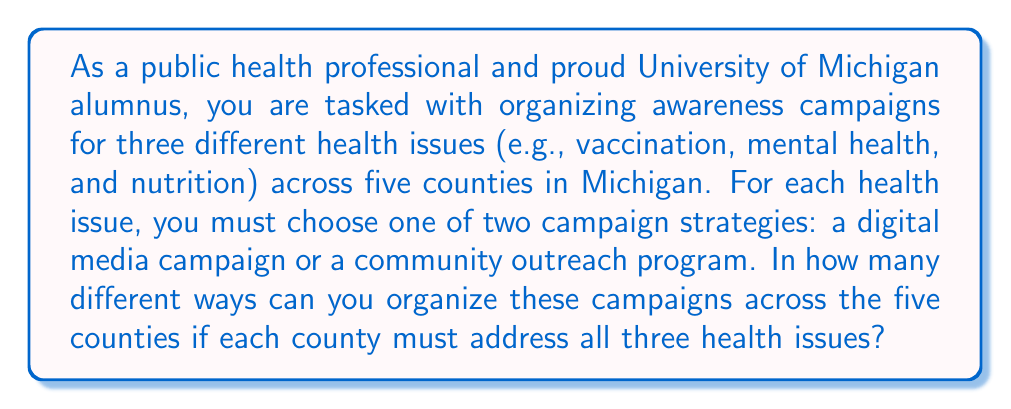Can you solve this math problem? Let's approach this step-by-step:

1) For each county, we need to make three independent decisions, one for each health issue.

2) For each health issue in each county, we have two choices: digital media campaign or community outreach program.

3) This scenario can be modeled as a sequence of choices, where we make 3 choices for each of the 5 counties.

4) For each individual choice, we have 2 options.

5) When we have a sequence of independent choices, we multiply the number of options for each choice.

6) In this case, we have:
   $$(2 \text{ choices})^{3 \text{ health issues}} = 2^3 = 8$$ possible combinations for each county.

7) We need to make this decision for each of the 5 counties independently.

8) Using the multiplication principle again, we multiply our result by itself 5 times:

   $$8^5 = (2^3)^5 = 2^{15} = 32,768$$

Therefore, there are 32,768 different ways to organize these campaigns across the five counties.
Answer: $2^{15} = 32,768$ ways 